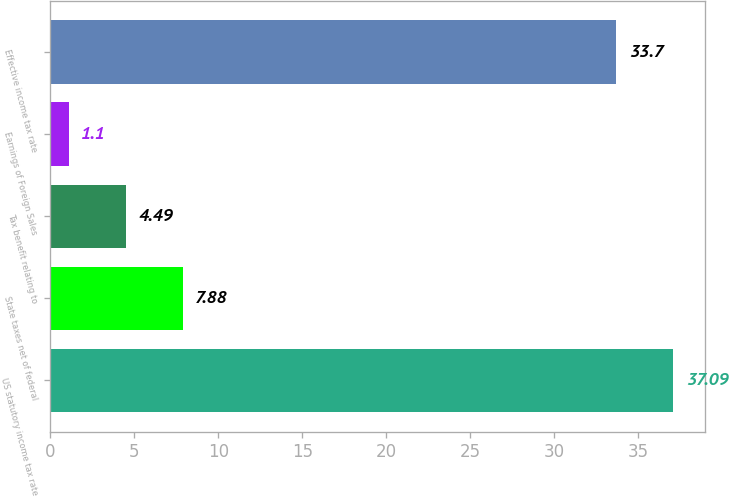Convert chart to OTSL. <chart><loc_0><loc_0><loc_500><loc_500><bar_chart><fcel>US statutory income tax rate<fcel>State taxes net of federal<fcel>Tax benefit relating to<fcel>Earnings of Foreign Sales<fcel>Effective income tax rate<nl><fcel>37.09<fcel>7.88<fcel>4.49<fcel>1.1<fcel>33.7<nl></chart> 